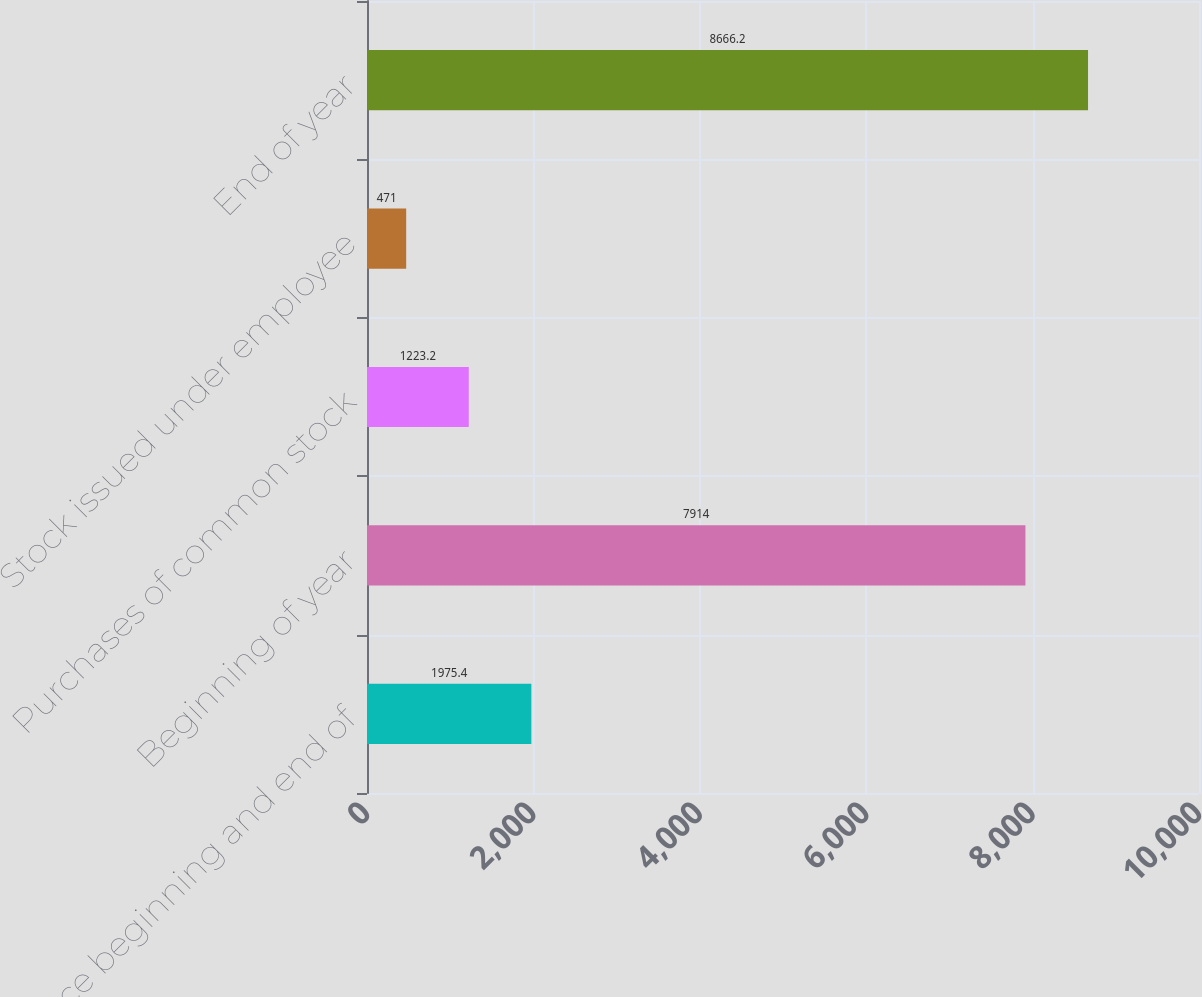<chart> <loc_0><loc_0><loc_500><loc_500><bar_chart><fcel>Balance beginning and end of<fcel>Beginning of year<fcel>Purchases of common stock<fcel>Stock issued under employee<fcel>End of year<nl><fcel>1975.4<fcel>7914<fcel>1223.2<fcel>471<fcel>8666.2<nl></chart> 